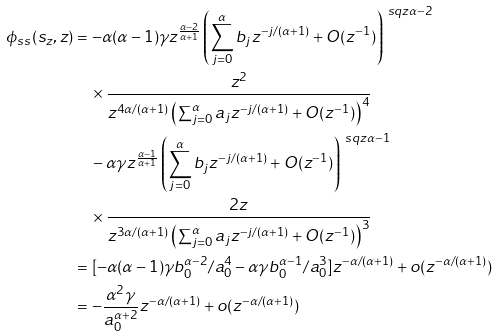<formula> <loc_0><loc_0><loc_500><loc_500>\phi _ { s s } ( s _ { z } , z ) & = - \alpha ( \alpha - 1 ) \gamma z ^ { \frac { \alpha - 2 } { \alpha + 1 } } \left ( \sum _ { j = 0 } ^ { \alpha } b _ { j } z ^ { - j / ( \alpha + 1 ) } + O ( z ^ { - 1 } ) \right ) ^ { \ s q z \alpha - 2 } \\ & \quad \times \frac { z ^ { 2 } } { z ^ { 4 \alpha / ( \alpha + 1 ) } \left ( \sum _ { j = 0 } ^ { \alpha } a _ { j } z ^ { - j / ( \alpha + 1 ) } + O ( z ^ { - 1 } ) \right ) ^ { 4 } } \\ & \quad - \alpha \gamma z ^ { \frac { \alpha - 1 } { \alpha + 1 } } \left ( \sum _ { j = 0 } ^ { \alpha } b _ { j } z ^ { - j / ( \alpha + 1 ) } + O ( z ^ { - 1 } ) \right ) ^ { \ s q z \alpha - 1 } \\ & \quad \times \frac { 2 z } { z ^ { 3 \alpha / ( \alpha + 1 ) } \left ( \sum _ { j = 0 } ^ { \alpha } a _ { j } z ^ { - j / ( \alpha + 1 ) } + O ( z ^ { - 1 } ) \right ) ^ { 3 } } \\ & = [ - \alpha ( \alpha - 1 ) \gamma b _ { 0 } ^ { \alpha - 2 } / a _ { 0 } ^ { 4 } - \alpha \gamma b _ { 0 } ^ { \alpha - 1 } / a _ { 0 } ^ { 3 } ] z ^ { - \alpha / ( \alpha + 1 ) } + o ( z ^ { - \alpha / ( \alpha + 1 ) } ) \\ & = - \frac { \alpha ^ { 2 } \gamma } { a _ { 0 } ^ { \alpha + 2 } } z ^ { - \alpha / ( \alpha + 1 ) } + o ( z ^ { - \alpha / ( \alpha + 1 ) } )</formula> 